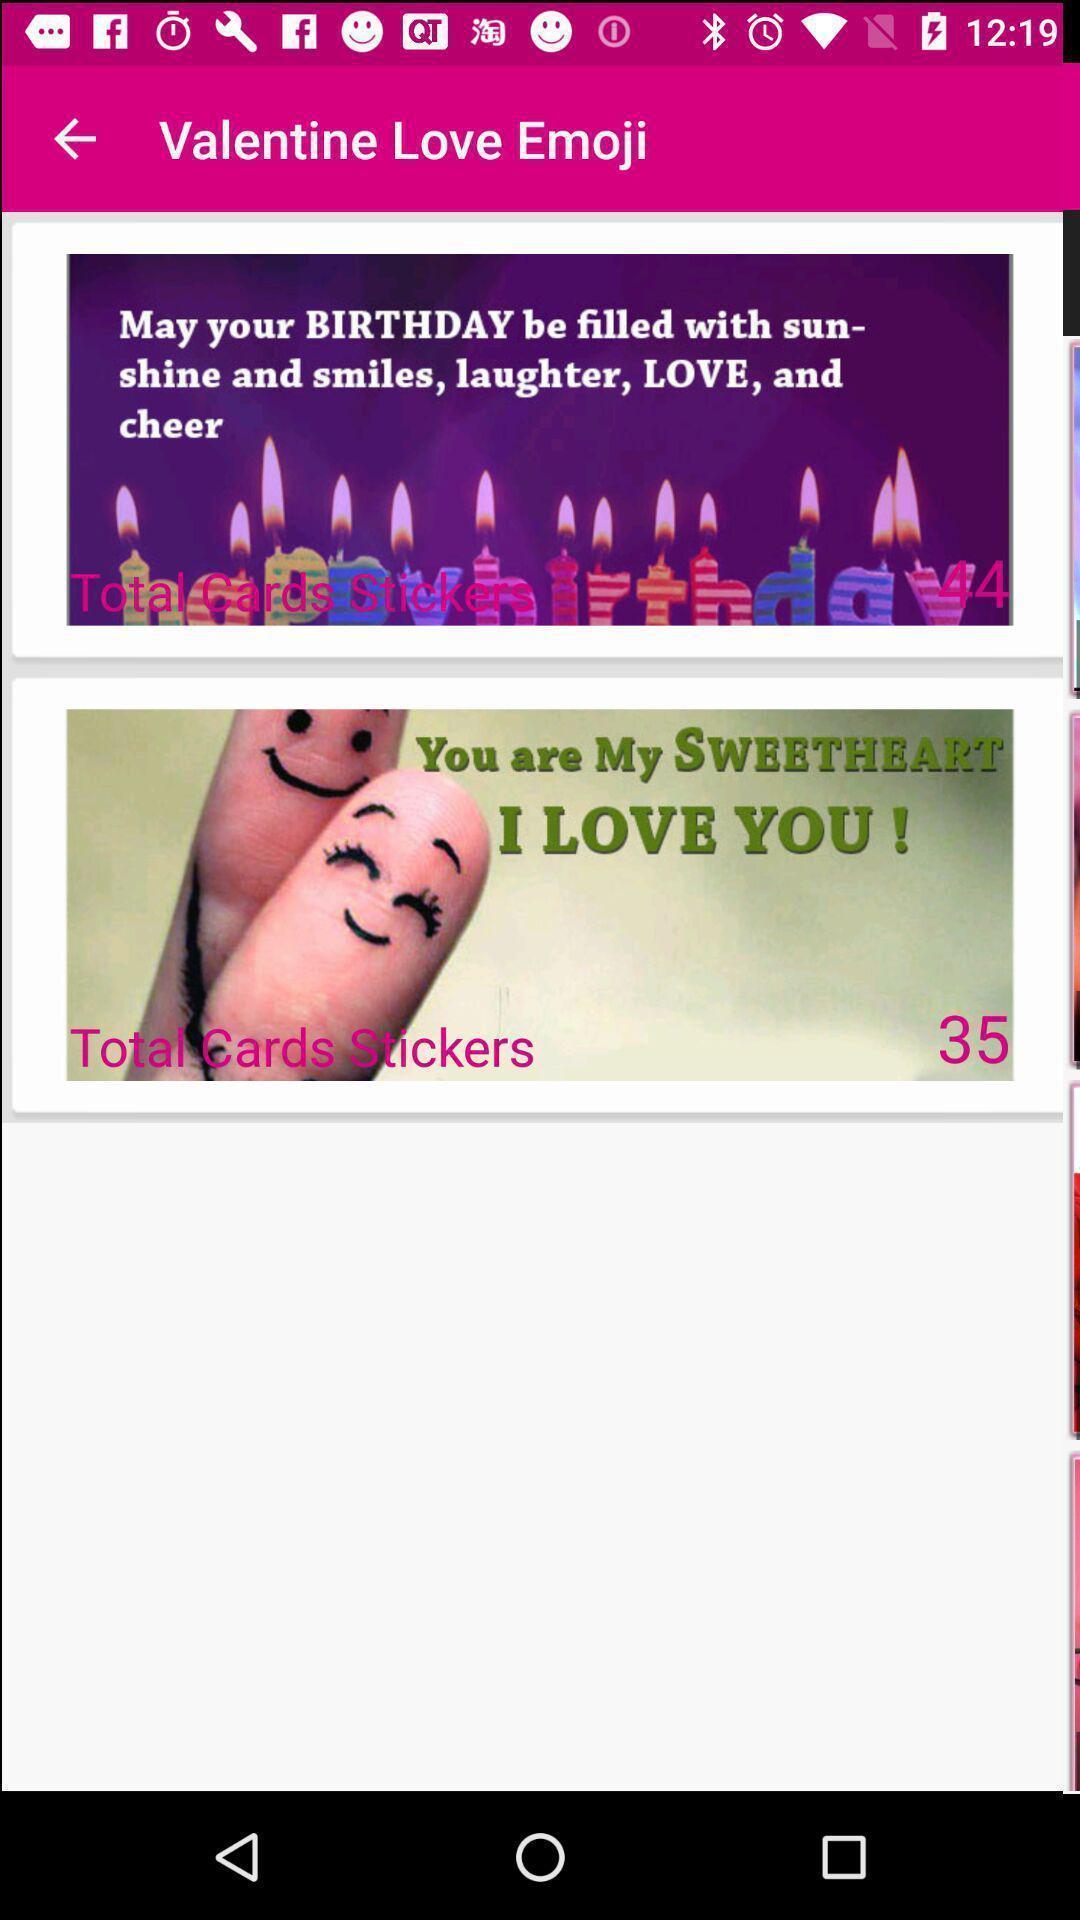What is the overall content of this screenshot? Screen showing stickers. 